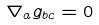Convert formula to latex. <formula><loc_0><loc_0><loc_500><loc_500>\nabla _ { a } g _ { b c } = 0</formula> 